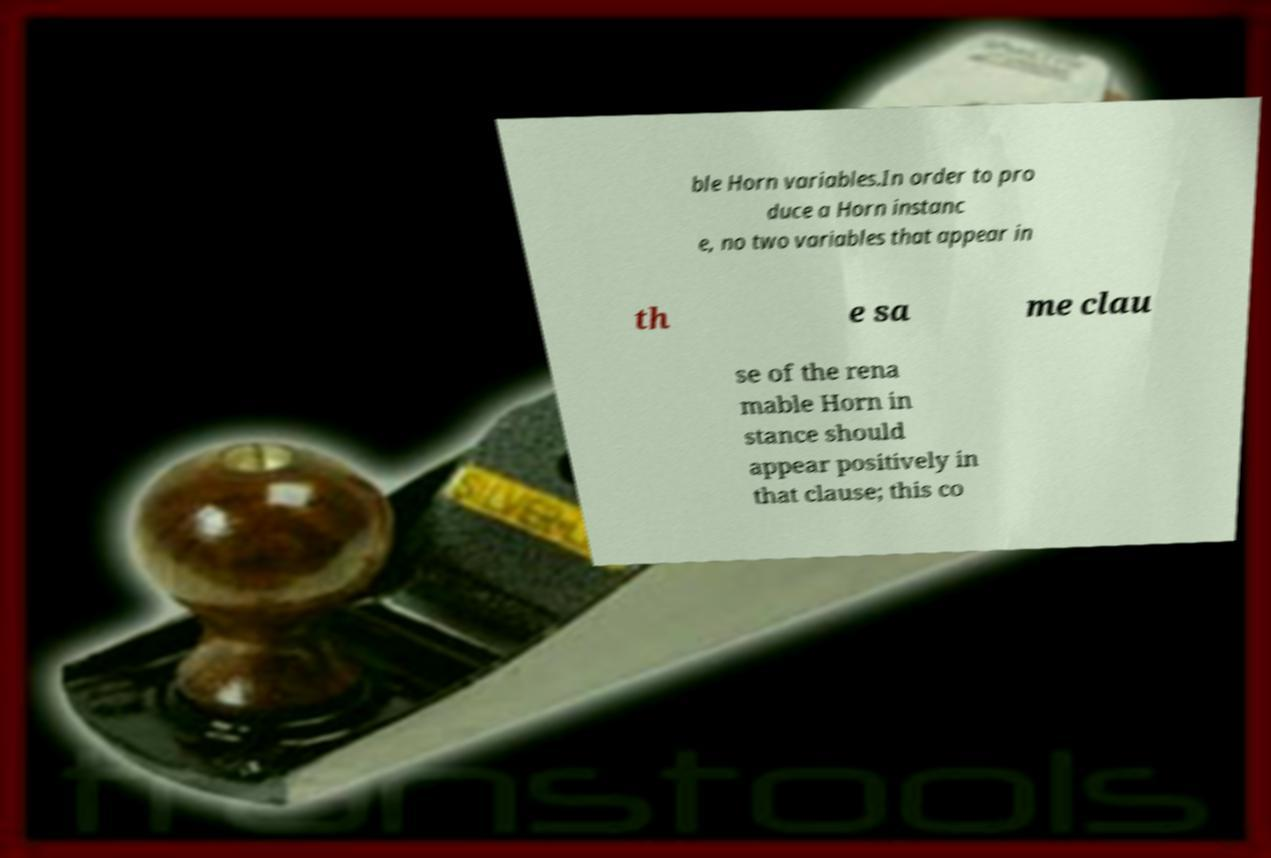I need the written content from this picture converted into text. Can you do that? ble Horn variables.In order to pro duce a Horn instanc e, no two variables that appear in th e sa me clau se of the rena mable Horn in stance should appear positively in that clause; this co 